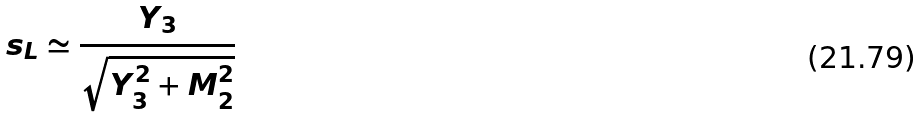Convert formula to latex. <formula><loc_0><loc_0><loc_500><loc_500>s _ { L } \simeq \frac { Y _ { 3 } } { \sqrt { Y _ { 3 } ^ { 2 } + M _ { 2 } ^ { 2 } } }</formula> 